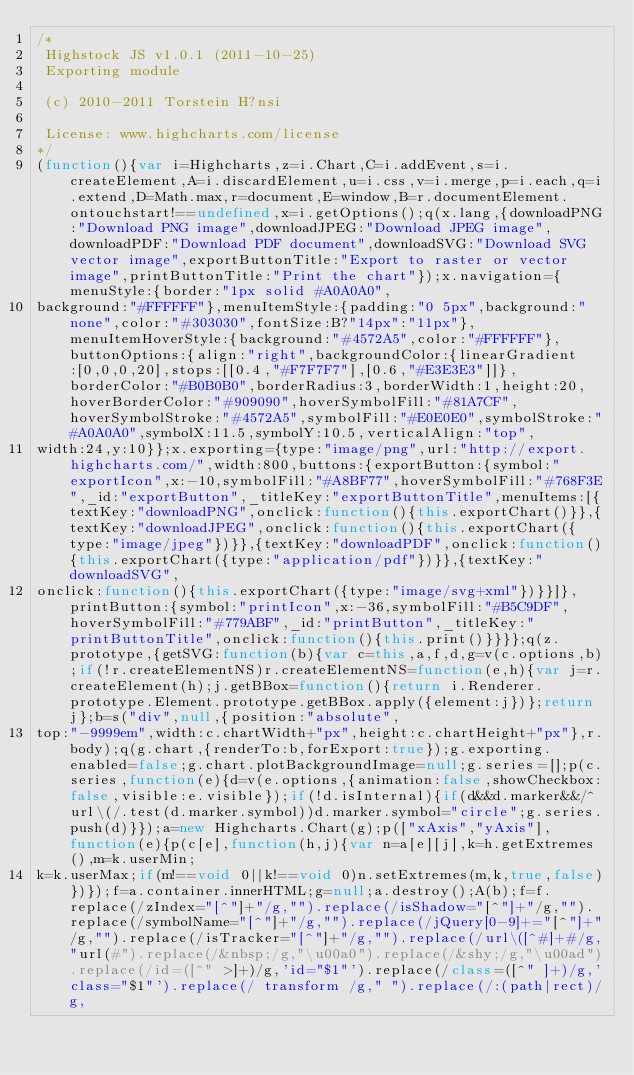<code> <loc_0><loc_0><loc_500><loc_500><_JavaScript_>/*
 Highstock JS v1.0.1 (2011-10-25)
 Exporting module

 (c) 2010-2011 Torstein H?nsi

 License: www.highcharts.com/license
*/
(function(){var i=Highcharts,z=i.Chart,C=i.addEvent,s=i.createElement,A=i.discardElement,u=i.css,v=i.merge,p=i.each,q=i.extend,D=Math.max,r=document,E=window,B=r.documentElement.ontouchstart!==undefined,x=i.getOptions();q(x.lang,{downloadPNG:"Download PNG image",downloadJPEG:"Download JPEG image",downloadPDF:"Download PDF document",downloadSVG:"Download SVG vector image",exportButtonTitle:"Export to raster or vector image",printButtonTitle:"Print the chart"});x.navigation={menuStyle:{border:"1px solid #A0A0A0",
background:"#FFFFFF"},menuItemStyle:{padding:"0 5px",background:"none",color:"#303030",fontSize:B?"14px":"11px"},menuItemHoverStyle:{background:"#4572A5",color:"#FFFFFF"},buttonOptions:{align:"right",backgroundColor:{linearGradient:[0,0,0,20],stops:[[0.4,"#F7F7F7"],[0.6,"#E3E3E3"]]},borderColor:"#B0B0B0",borderRadius:3,borderWidth:1,height:20,hoverBorderColor:"#909090",hoverSymbolFill:"#81A7CF",hoverSymbolStroke:"#4572A5",symbolFill:"#E0E0E0",symbolStroke:"#A0A0A0",symbolX:11.5,symbolY:10.5,verticalAlign:"top",
width:24,y:10}};x.exporting={type:"image/png",url:"http://export.highcharts.com/",width:800,buttons:{exportButton:{symbol:"exportIcon",x:-10,symbolFill:"#A8BF77",hoverSymbolFill:"#768F3E",_id:"exportButton",_titleKey:"exportButtonTitle",menuItems:[{textKey:"downloadPNG",onclick:function(){this.exportChart()}},{textKey:"downloadJPEG",onclick:function(){this.exportChart({type:"image/jpeg"})}},{textKey:"downloadPDF",onclick:function(){this.exportChart({type:"application/pdf"})}},{textKey:"downloadSVG",
onclick:function(){this.exportChart({type:"image/svg+xml"})}}]},printButton:{symbol:"printIcon",x:-36,symbolFill:"#B5C9DF",hoverSymbolFill:"#779ABF",_id:"printButton",_titleKey:"printButtonTitle",onclick:function(){this.print()}}}};q(z.prototype,{getSVG:function(b){var c=this,a,f,d,g=v(c.options,b);if(!r.createElementNS)r.createElementNS=function(e,h){var j=r.createElement(h);j.getBBox=function(){return i.Renderer.prototype.Element.prototype.getBBox.apply({element:j})};return j};b=s("div",null,{position:"absolute",
top:"-9999em",width:c.chartWidth+"px",height:c.chartHeight+"px"},r.body);q(g.chart,{renderTo:b,forExport:true});g.exporting.enabled=false;g.chart.plotBackgroundImage=null;g.series=[];p(c.series,function(e){d=v(e.options,{animation:false,showCheckbox:false,visible:e.visible});if(!d.isInternal){if(d&&d.marker&&/^url\(/.test(d.marker.symbol))d.marker.symbol="circle";g.series.push(d)}});a=new Highcharts.Chart(g);p(["xAxis","yAxis"],function(e){p(c[e],function(h,j){var n=a[e][j],k=h.getExtremes(),m=k.userMin;
k=k.userMax;if(m!==void 0||k!==void 0)n.setExtremes(m,k,true,false)})});f=a.container.innerHTML;g=null;a.destroy();A(b);f=f.replace(/zIndex="[^"]+"/g,"").replace(/isShadow="[^"]+"/g,"").replace(/symbolName="[^"]+"/g,"").replace(/jQuery[0-9]+="[^"]+"/g,"").replace(/isTracker="[^"]+"/g,"").replace(/url\([^#]+#/g,"url(#").replace(/&nbsp;/g,"\u00a0").replace(/&shy;/g,"\u00ad").replace(/id=([^" >]+)/g,'id="$1"').replace(/class=([^" ]+)/g,'class="$1"').replace(/ transform /g," ").replace(/:(path|rect)/g,</code> 